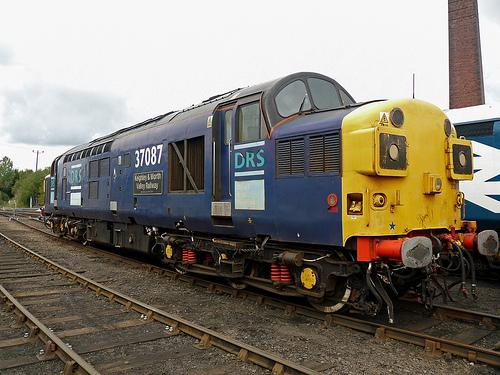Question: what is in the foreground of the photo?
Choices:
A. Street.
B. Train tracks.
C. City.
D. Home.
Answer with the letter. Answer: B Question: what is the main color of the train?
Choices:
A. Green.
B. Red.
C. White.
D. Blue.
Answer with the letter. Answer: D Question: what do the three letters on the side of the train say?
Choices:
A. Drz.
B. Drt.
C. DRS.
D. Drd.
Answer with the letter. Answer: C 